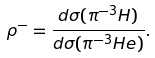<formula> <loc_0><loc_0><loc_500><loc_500>\rho ^ { - } = \frac { d \sigma ( \pi ^ { - 3 } H ) } { d \sigma ( \pi ^ { - 3 } H e ) } .</formula> 